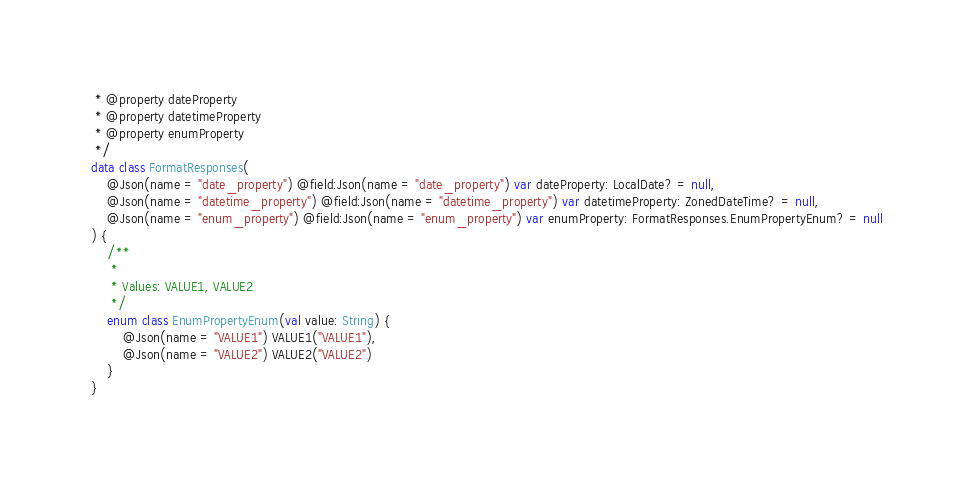<code> <loc_0><loc_0><loc_500><loc_500><_Kotlin_> * @property dateProperty
 * @property datetimeProperty
 * @property enumProperty
 */
data class FormatResponses(
    @Json(name = "date_property") @field:Json(name = "date_property") var dateProperty: LocalDate? = null,
    @Json(name = "datetime_property") @field:Json(name = "datetime_property") var datetimeProperty: ZonedDateTime? = null,
    @Json(name = "enum_property") @field:Json(name = "enum_property") var enumProperty: FormatResponses.EnumPropertyEnum? = null
) {
    /**
     *
     * Values: VALUE1, VALUE2
     */
    enum class EnumPropertyEnum(val value: String) {
        @Json(name = "VALUE1") VALUE1("VALUE1"),
        @Json(name = "VALUE2") VALUE2("VALUE2")
    }
}
</code> 